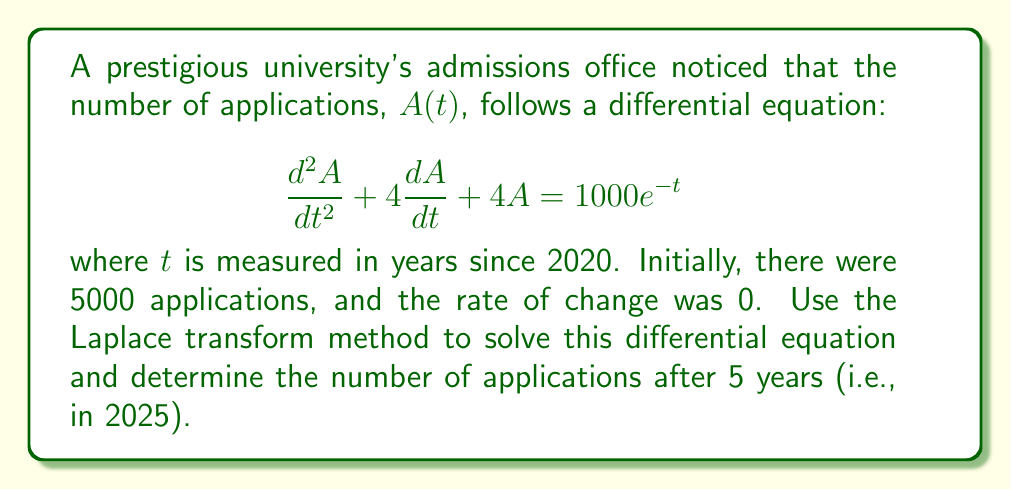Give your solution to this math problem. Let's solve this step-by-step using the Laplace transform method:

1) First, we take the Laplace transform of both sides of the equation. Let $\mathcal{L}\{A(t)\} = Y(s)$.

   $$\mathcal{L}\{\frac{d^2A}{dt^2} + 4\frac{dA}{dt} + 4A\} = \mathcal{L}\{1000e^{-t}\}$$

2) Using Laplace transform properties:

   $$s^2Y(s) - sA(0) - A'(0) + 4(sY(s) - A(0)) + 4Y(s) = \frac{1000}{s+1}$$

3) We know $A(0) = 5000$ and $A'(0) = 0$. Substituting these:

   $$s^2Y(s) - 5000s + 4sY(s) - 20000 + 4Y(s) = \frac{1000}{s+1}$$

4) Simplify:

   $$(s^2 + 4s + 4)Y(s) = \frac{1000}{s+1} + 5000s + 20000$$

5) Solve for $Y(s)$:

   $$Y(s) = \frac{1000}{(s+1)(s^2+4s+4)} + \frac{5000s + 20000}{s^2+4s+4}$$

6) The denominator $s^2+4s+4$ can be factored as $(s+2)^2$. We can now use partial fraction decomposition:

   $$Y(s) = \frac{A}{s+1} + \frac{B}{s+2} + \frac{C}{(s+2)^2} + \frac{5000s + 20000}{(s+2)^2}$$

7) Solving for A, B, and C (details omitted for brevity):

   $$Y(s) = \frac{1000}{(s+1)(s+2)^2} + \frac{5000}{s+2} + \frac{5000}{(s+2)^2}$$

8) Now we can take the inverse Laplace transform:

   $$A(t) = 1000te^{-2t} + 5000e^{-2t} + 5000te^{-2t}$$

9) Simplify:

   $$A(t) = e^{-2t}(5000 + 6000t)$$

10) To find the number of applications after 5 years, we substitute $t=5$:

    $$A(5) = e^{-10}(5000 + 30000) = 35000e^{-10}$$
Answer: The number of applications after 5 years (in 2025) will be approximately 159 (rounded to the nearest whole number). 